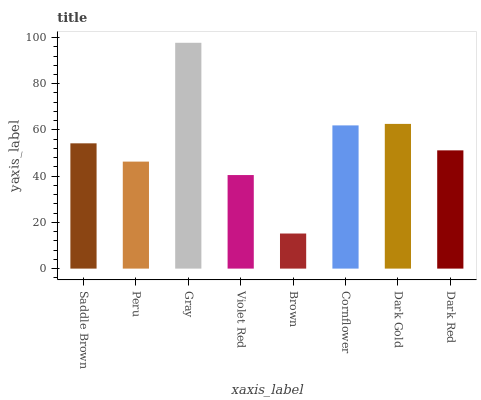Is Brown the minimum?
Answer yes or no. Yes. Is Gray the maximum?
Answer yes or no. Yes. Is Peru the minimum?
Answer yes or no. No. Is Peru the maximum?
Answer yes or no. No. Is Saddle Brown greater than Peru?
Answer yes or no. Yes. Is Peru less than Saddle Brown?
Answer yes or no. Yes. Is Peru greater than Saddle Brown?
Answer yes or no. No. Is Saddle Brown less than Peru?
Answer yes or no. No. Is Saddle Brown the high median?
Answer yes or no. Yes. Is Dark Red the low median?
Answer yes or no. Yes. Is Peru the high median?
Answer yes or no. No. Is Brown the low median?
Answer yes or no. No. 